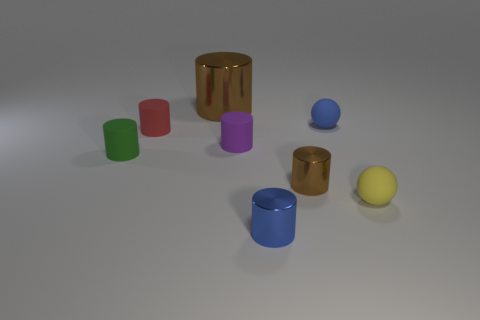What is the shape of the tiny object that is the same color as the large metallic object? cylinder 